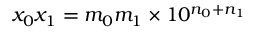Convert formula to latex. <formula><loc_0><loc_0><loc_500><loc_500>x _ { 0 } x _ { 1 } = m _ { 0 } m _ { 1 } \times 1 0 ^ { n _ { 0 } + n _ { 1 } }</formula> 